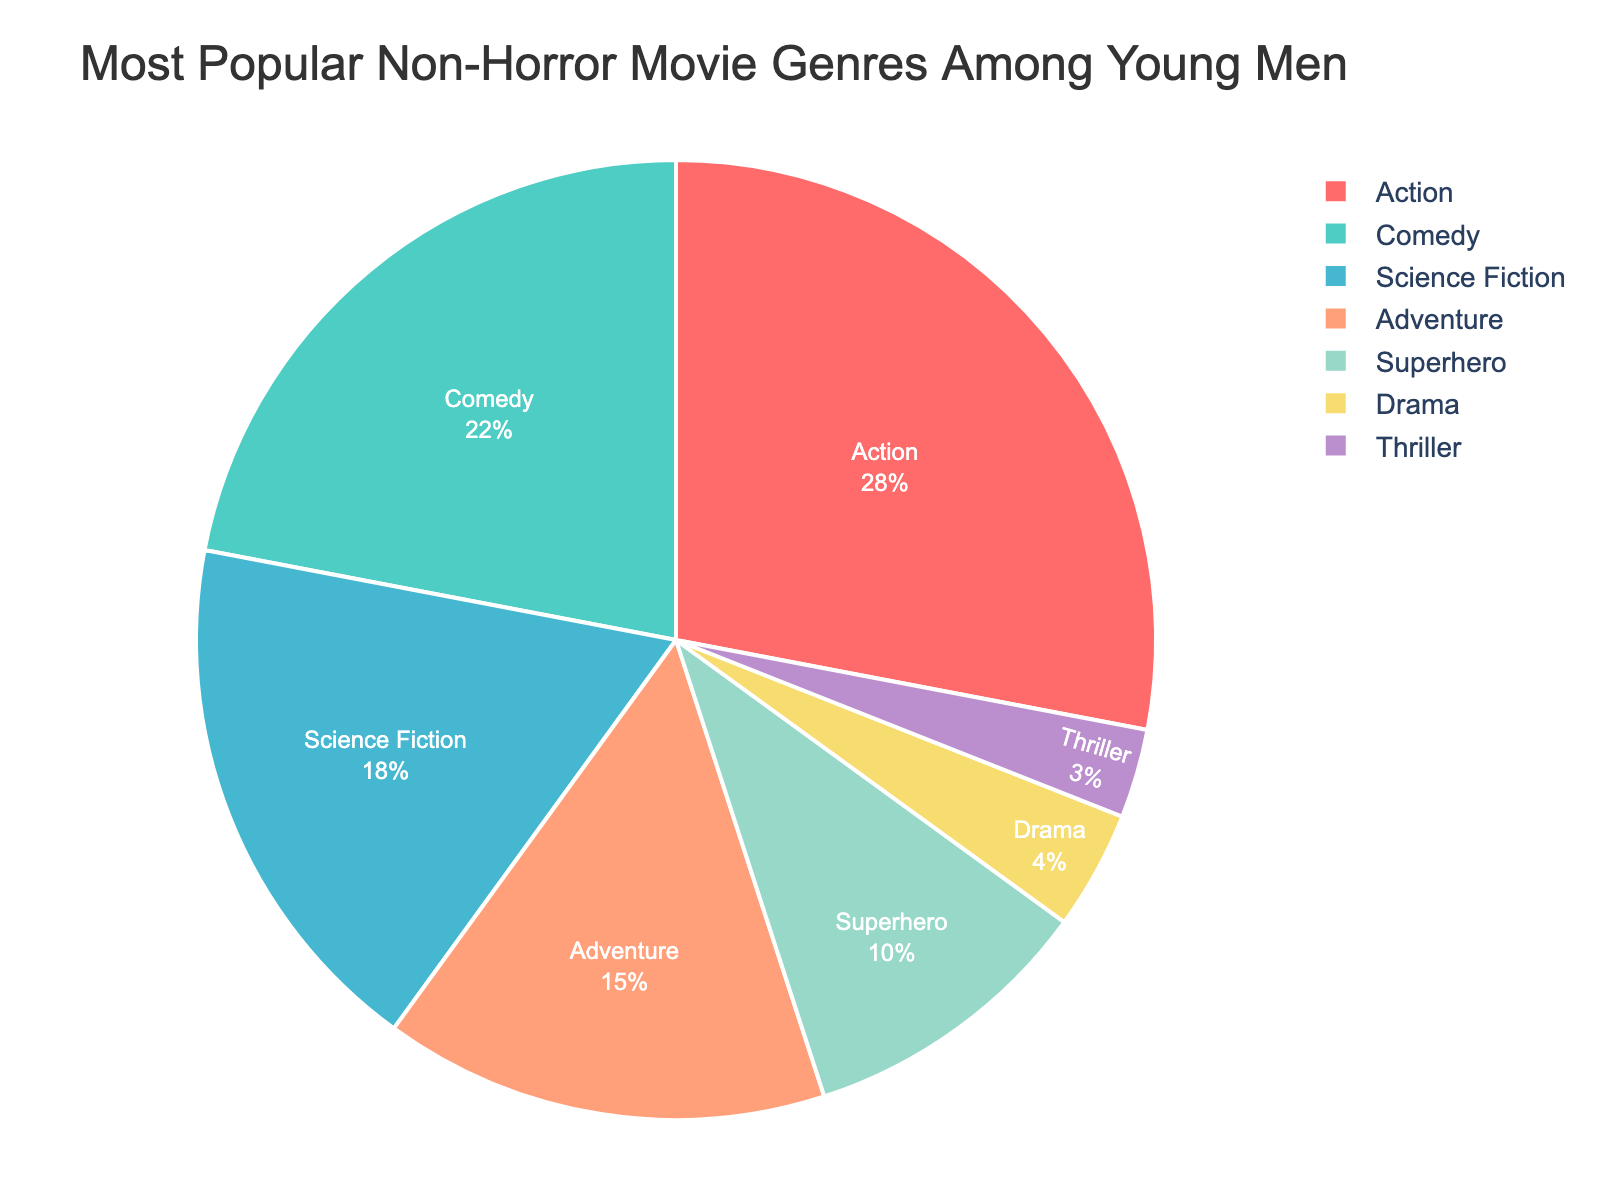Which movie genre is the most popular among young men? The chart shows different genres and their respective percentages. The highest percentage indicates the most popular genre. The action genre has the highest percentage at 28%.
Answer: Action Compare the popularity of Comedy and Science Fiction genres. Which one is higher? The percentages for Comedy and Science Fiction are 22% and 18% respectively. 22% is greater than 18%, so Comedy is more popular than Science Fiction.
Answer: Comedy What is the total percentage of the top three most popular genres combined? The top three genres by percentage are Action (28%), Comedy (22%), and Science Fiction (18%). Adding these gives 28 + 22 + 18 = 68%.
Answer: 68% Which genre has the smallest share of popularity among young men? The genre with the smallest percentage indicates the least popular genre. Thriller has the smallest percentage at 3%.
Answer: Thriller What is the difference in popularity between Adventure and Drama genres? The percentages for Adventure and Drama are 15% and 4% respectively. The difference is 15 - 4 = 11%.
Answer: 11% Are there more young men interested in Superhero movies than in Adventure movies? The percentages for Superhero and Adventure genres are 10% and 15% respectively. Since 10% is less than 15%, fewer young men are interested in Superhero movies compared to Adventure movies.
Answer: No Which genre has a popularity percentage closest to 20%? Among the genres listed, Comedy has a percentage closest to 20%, at 22%.
Answer: Comedy How does the popularity of Drama compare to that of Thriller? The percentages for Drama and Thriller are 4% and 3% respectively. Since 4% is greater than 3%, Drama is more popular than Thriller among young men.
Answer: Drama What is the combined popularity percentage of Superhero and Adventure genres? The percentages for Superhero and Adventure genres are 10% and 15% respectively. Adding these together gives 10 + 15 = 25%.
Answer: 25% Is the popularity of Science Fiction more than double that of Drama? The percentage for Science Fiction is 18% and for Drama is 4%. Doubling Drama's percentage gives 4 * 2 = 8%. Since 18% is greater than 8%, Science Fiction's popularity is more than double that of Drama.
Answer: Yes 